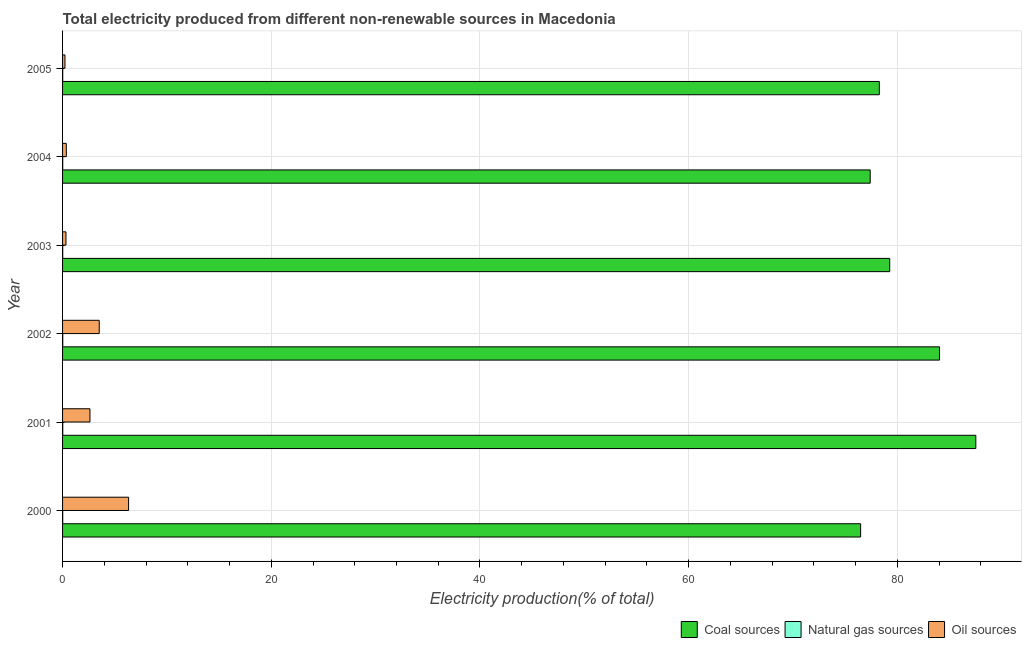Are the number of bars per tick equal to the number of legend labels?
Your answer should be compact. Yes. Are the number of bars on each tick of the Y-axis equal?
Your answer should be compact. Yes. How many bars are there on the 3rd tick from the bottom?
Your response must be concise. 3. What is the label of the 6th group of bars from the top?
Give a very brief answer. 2000. In how many cases, is the number of bars for a given year not equal to the number of legend labels?
Your answer should be very brief. 0. What is the percentage of electricity produced by coal in 2005?
Offer a terse response. 78.27. Across all years, what is the maximum percentage of electricity produced by coal?
Provide a short and direct response. 87.52. Across all years, what is the minimum percentage of electricity produced by oil sources?
Your answer should be compact. 0.23. What is the total percentage of electricity produced by coal in the graph?
Give a very brief answer. 482.98. What is the difference between the percentage of electricity produced by oil sources in 2000 and that in 2001?
Your response must be concise. 3.7. What is the difference between the percentage of electricity produced by coal in 2000 and the percentage of electricity produced by natural gas in 2003?
Make the answer very short. 76.46. What is the average percentage of electricity produced by natural gas per year?
Your answer should be compact. 0.01. In the year 2005, what is the difference between the percentage of electricity produced by natural gas and percentage of electricity produced by coal?
Offer a terse response. -78.26. In how many years, is the percentage of electricity produced by coal greater than 12 %?
Give a very brief answer. 6. What is the ratio of the percentage of electricity produced by oil sources in 2001 to that in 2005?
Keep it short and to the point. 11.39. Is the percentage of electricity produced by coal in 2002 less than that in 2003?
Provide a succinct answer. No. Is the difference between the percentage of electricity produced by coal in 2001 and 2002 greater than the difference between the percentage of electricity produced by oil sources in 2001 and 2002?
Keep it short and to the point. Yes. What is the difference between the highest and the second highest percentage of electricity produced by oil sources?
Ensure brevity in your answer.  2.81. What is the difference between the highest and the lowest percentage of electricity produced by natural gas?
Offer a terse response. 0. What does the 3rd bar from the top in 2004 represents?
Your response must be concise. Coal sources. What does the 2nd bar from the bottom in 2004 represents?
Your answer should be compact. Natural gas sources. Is it the case that in every year, the sum of the percentage of electricity produced by coal and percentage of electricity produced by natural gas is greater than the percentage of electricity produced by oil sources?
Your response must be concise. Yes. How many years are there in the graph?
Keep it short and to the point. 6. Are the values on the major ticks of X-axis written in scientific E-notation?
Keep it short and to the point. No. Where does the legend appear in the graph?
Your response must be concise. Bottom right. How many legend labels are there?
Your answer should be compact. 3. What is the title of the graph?
Give a very brief answer. Total electricity produced from different non-renewable sources in Macedonia. What is the label or title of the X-axis?
Keep it short and to the point. Electricity production(% of total). What is the Electricity production(% of total) in Coal sources in 2000?
Your answer should be very brief. 76.48. What is the Electricity production(% of total) of Natural gas sources in 2000?
Offer a terse response. 0.01. What is the Electricity production(% of total) in Oil sources in 2000?
Offer a terse response. 6.33. What is the Electricity production(% of total) in Coal sources in 2001?
Make the answer very short. 87.52. What is the Electricity production(% of total) in Natural gas sources in 2001?
Your response must be concise. 0.02. What is the Electricity production(% of total) of Oil sources in 2001?
Your response must be concise. 2.62. What is the Electricity production(% of total) in Coal sources in 2002?
Provide a succinct answer. 84.04. What is the Electricity production(% of total) of Natural gas sources in 2002?
Keep it short and to the point. 0.02. What is the Electricity production(% of total) in Oil sources in 2002?
Make the answer very short. 3.51. What is the Electricity production(% of total) in Coal sources in 2003?
Offer a terse response. 79.27. What is the Electricity production(% of total) in Natural gas sources in 2003?
Your answer should be very brief. 0.01. What is the Electricity production(% of total) in Oil sources in 2003?
Offer a very short reply. 0.33. What is the Electricity production(% of total) in Coal sources in 2004?
Ensure brevity in your answer.  77.4. What is the Electricity production(% of total) of Natural gas sources in 2004?
Make the answer very short. 0.01. What is the Electricity production(% of total) of Oil sources in 2004?
Offer a very short reply. 0.36. What is the Electricity production(% of total) in Coal sources in 2005?
Offer a terse response. 78.27. What is the Electricity production(% of total) in Natural gas sources in 2005?
Give a very brief answer. 0.01. What is the Electricity production(% of total) in Oil sources in 2005?
Provide a short and direct response. 0.23. Across all years, what is the maximum Electricity production(% of total) of Coal sources?
Make the answer very short. 87.52. Across all years, what is the maximum Electricity production(% of total) in Natural gas sources?
Your answer should be very brief. 0.02. Across all years, what is the maximum Electricity production(% of total) of Oil sources?
Provide a short and direct response. 6.33. Across all years, what is the minimum Electricity production(% of total) in Coal sources?
Offer a very short reply. 76.48. Across all years, what is the minimum Electricity production(% of total) in Natural gas sources?
Provide a succinct answer. 0.01. Across all years, what is the minimum Electricity production(% of total) in Oil sources?
Your answer should be very brief. 0.23. What is the total Electricity production(% of total) in Coal sources in the graph?
Offer a very short reply. 482.98. What is the total Electricity production(% of total) in Natural gas sources in the graph?
Your answer should be very brief. 0.09. What is the total Electricity production(% of total) in Oil sources in the graph?
Ensure brevity in your answer.  13.38. What is the difference between the Electricity production(% of total) of Coal sources in 2000 and that in 2001?
Provide a short and direct response. -11.04. What is the difference between the Electricity production(% of total) in Natural gas sources in 2000 and that in 2001?
Give a very brief answer. -0. What is the difference between the Electricity production(% of total) in Oil sources in 2000 and that in 2001?
Your answer should be compact. 3.7. What is the difference between the Electricity production(% of total) in Coal sources in 2000 and that in 2002?
Provide a short and direct response. -7.56. What is the difference between the Electricity production(% of total) in Natural gas sources in 2000 and that in 2002?
Offer a terse response. -0. What is the difference between the Electricity production(% of total) in Oil sources in 2000 and that in 2002?
Give a very brief answer. 2.81. What is the difference between the Electricity production(% of total) of Coal sources in 2000 and that in 2003?
Provide a short and direct response. -2.79. What is the difference between the Electricity production(% of total) of Natural gas sources in 2000 and that in 2003?
Provide a succinct answer. -0. What is the difference between the Electricity production(% of total) of Oil sources in 2000 and that in 2003?
Give a very brief answer. 6. What is the difference between the Electricity production(% of total) in Coal sources in 2000 and that in 2004?
Make the answer very short. -0.92. What is the difference between the Electricity production(% of total) of Natural gas sources in 2000 and that in 2004?
Provide a succinct answer. -0. What is the difference between the Electricity production(% of total) in Oil sources in 2000 and that in 2004?
Offer a terse response. 5.97. What is the difference between the Electricity production(% of total) of Coal sources in 2000 and that in 2005?
Give a very brief answer. -1.79. What is the difference between the Electricity production(% of total) in Oil sources in 2000 and that in 2005?
Offer a terse response. 6.1. What is the difference between the Electricity production(% of total) of Coal sources in 2001 and that in 2002?
Provide a short and direct response. 3.48. What is the difference between the Electricity production(% of total) of Natural gas sources in 2001 and that in 2002?
Offer a very short reply. -0. What is the difference between the Electricity production(% of total) in Oil sources in 2001 and that in 2002?
Your answer should be very brief. -0.89. What is the difference between the Electricity production(% of total) of Coal sources in 2001 and that in 2003?
Offer a terse response. 8.25. What is the difference between the Electricity production(% of total) of Natural gas sources in 2001 and that in 2003?
Your response must be concise. 0. What is the difference between the Electricity production(% of total) in Oil sources in 2001 and that in 2003?
Provide a succinct answer. 2.3. What is the difference between the Electricity production(% of total) in Coal sources in 2001 and that in 2004?
Provide a succinct answer. 10.12. What is the difference between the Electricity production(% of total) of Natural gas sources in 2001 and that in 2004?
Offer a terse response. 0. What is the difference between the Electricity production(% of total) of Oil sources in 2001 and that in 2004?
Give a very brief answer. 2.27. What is the difference between the Electricity production(% of total) of Coal sources in 2001 and that in 2005?
Offer a very short reply. 9.25. What is the difference between the Electricity production(% of total) of Natural gas sources in 2001 and that in 2005?
Keep it short and to the point. 0. What is the difference between the Electricity production(% of total) in Oil sources in 2001 and that in 2005?
Provide a short and direct response. 2.39. What is the difference between the Electricity production(% of total) of Coal sources in 2002 and that in 2003?
Your response must be concise. 4.78. What is the difference between the Electricity production(% of total) of Natural gas sources in 2002 and that in 2003?
Your response must be concise. 0. What is the difference between the Electricity production(% of total) in Oil sources in 2002 and that in 2003?
Give a very brief answer. 3.19. What is the difference between the Electricity production(% of total) in Coal sources in 2002 and that in 2004?
Offer a terse response. 6.65. What is the difference between the Electricity production(% of total) of Natural gas sources in 2002 and that in 2004?
Give a very brief answer. 0. What is the difference between the Electricity production(% of total) of Oil sources in 2002 and that in 2004?
Provide a short and direct response. 3.15. What is the difference between the Electricity production(% of total) in Coal sources in 2002 and that in 2005?
Give a very brief answer. 5.77. What is the difference between the Electricity production(% of total) in Natural gas sources in 2002 and that in 2005?
Provide a short and direct response. 0. What is the difference between the Electricity production(% of total) of Oil sources in 2002 and that in 2005?
Ensure brevity in your answer.  3.28. What is the difference between the Electricity production(% of total) of Coal sources in 2003 and that in 2004?
Provide a short and direct response. 1.87. What is the difference between the Electricity production(% of total) of Natural gas sources in 2003 and that in 2004?
Your answer should be very brief. -0. What is the difference between the Electricity production(% of total) of Oil sources in 2003 and that in 2004?
Provide a short and direct response. -0.03. What is the difference between the Electricity production(% of total) of Coal sources in 2003 and that in 2005?
Ensure brevity in your answer.  0.99. What is the difference between the Electricity production(% of total) in Natural gas sources in 2003 and that in 2005?
Your answer should be compact. 0. What is the difference between the Electricity production(% of total) of Oil sources in 2003 and that in 2005?
Give a very brief answer. 0.1. What is the difference between the Electricity production(% of total) of Coal sources in 2004 and that in 2005?
Your answer should be very brief. -0.88. What is the difference between the Electricity production(% of total) of Natural gas sources in 2004 and that in 2005?
Provide a succinct answer. 0. What is the difference between the Electricity production(% of total) in Oil sources in 2004 and that in 2005?
Provide a succinct answer. 0.13. What is the difference between the Electricity production(% of total) in Coal sources in 2000 and the Electricity production(% of total) in Natural gas sources in 2001?
Your answer should be very brief. 76.46. What is the difference between the Electricity production(% of total) in Coal sources in 2000 and the Electricity production(% of total) in Oil sources in 2001?
Offer a terse response. 73.85. What is the difference between the Electricity production(% of total) in Natural gas sources in 2000 and the Electricity production(% of total) in Oil sources in 2001?
Keep it short and to the point. -2.61. What is the difference between the Electricity production(% of total) in Coal sources in 2000 and the Electricity production(% of total) in Natural gas sources in 2002?
Make the answer very short. 76.46. What is the difference between the Electricity production(% of total) in Coal sources in 2000 and the Electricity production(% of total) in Oil sources in 2002?
Provide a succinct answer. 72.97. What is the difference between the Electricity production(% of total) in Natural gas sources in 2000 and the Electricity production(% of total) in Oil sources in 2002?
Offer a terse response. -3.5. What is the difference between the Electricity production(% of total) of Coal sources in 2000 and the Electricity production(% of total) of Natural gas sources in 2003?
Offer a very short reply. 76.46. What is the difference between the Electricity production(% of total) of Coal sources in 2000 and the Electricity production(% of total) of Oil sources in 2003?
Make the answer very short. 76.15. What is the difference between the Electricity production(% of total) in Natural gas sources in 2000 and the Electricity production(% of total) in Oil sources in 2003?
Your answer should be very brief. -0.31. What is the difference between the Electricity production(% of total) in Coal sources in 2000 and the Electricity production(% of total) in Natural gas sources in 2004?
Keep it short and to the point. 76.46. What is the difference between the Electricity production(% of total) in Coal sources in 2000 and the Electricity production(% of total) in Oil sources in 2004?
Make the answer very short. 76.12. What is the difference between the Electricity production(% of total) of Natural gas sources in 2000 and the Electricity production(% of total) of Oil sources in 2004?
Keep it short and to the point. -0.35. What is the difference between the Electricity production(% of total) in Coal sources in 2000 and the Electricity production(% of total) in Natural gas sources in 2005?
Keep it short and to the point. 76.46. What is the difference between the Electricity production(% of total) in Coal sources in 2000 and the Electricity production(% of total) in Oil sources in 2005?
Give a very brief answer. 76.25. What is the difference between the Electricity production(% of total) of Natural gas sources in 2000 and the Electricity production(% of total) of Oil sources in 2005?
Your response must be concise. -0.22. What is the difference between the Electricity production(% of total) of Coal sources in 2001 and the Electricity production(% of total) of Natural gas sources in 2002?
Keep it short and to the point. 87.5. What is the difference between the Electricity production(% of total) of Coal sources in 2001 and the Electricity production(% of total) of Oil sources in 2002?
Offer a terse response. 84.01. What is the difference between the Electricity production(% of total) of Natural gas sources in 2001 and the Electricity production(% of total) of Oil sources in 2002?
Offer a very short reply. -3.5. What is the difference between the Electricity production(% of total) in Coal sources in 2001 and the Electricity production(% of total) in Natural gas sources in 2003?
Provide a succinct answer. 87.5. What is the difference between the Electricity production(% of total) of Coal sources in 2001 and the Electricity production(% of total) of Oil sources in 2003?
Your answer should be compact. 87.19. What is the difference between the Electricity production(% of total) in Natural gas sources in 2001 and the Electricity production(% of total) in Oil sources in 2003?
Make the answer very short. -0.31. What is the difference between the Electricity production(% of total) in Coal sources in 2001 and the Electricity production(% of total) in Natural gas sources in 2004?
Provide a short and direct response. 87.5. What is the difference between the Electricity production(% of total) in Coal sources in 2001 and the Electricity production(% of total) in Oil sources in 2004?
Your answer should be very brief. 87.16. What is the difference between the Electricity production(% of total) in Natural gas sources in 2001 and the Electricity production(% of total) in Oil sources in 2004?
Provide a short and direct response. -0.34. What is the difference between the Electricity production(% of total) of Coal sources in 2001 and the Electricity production(% of total) of Natural gas sources in 2005?
Give a very brief answer. 87.51. What is the difference between the Electricity production(% of total) of Coal sources in 2001 and the Electricity production(% of total) of Oil sources in 2005?
Offer a very short reply. 87.29. What is the difference between the Electricity production(% of total) of Natural gas sources in 2001 and the Electricity production(% of total) of Oil sources in 2005?
Offer a terse response. -0.21. What is the difference between the Electricity production(% of total) of Coal sources in 2002 and the Electricity production(% of total) of Natural gas sources in 2003?
Offer a terse response. 84.03. What is the difference between the Electricity production(% of total) in Coal sources in 2002 and the Electricity production(% of total) in Oil sources in 2003?
Provide a short and direct response. 83.72. What is the difference between the Electricity production(% of total) of Natural gas sources in 2002 and the Electricity production(% of total) of Oil sources in 2003?
Offer a very short reply. -0.31. What is the difference between the Electricity production(% of total) of Coal sources in 2002 and the Electricity production(% of total) of Natural gas sources in 2004?
Offer a terse response. 84.03. What is the difference between the Electricity production(% of total) in Coal sources in 2002 and the Electricity production(% of total) in Oil sources in 2004?
Your answer should be compact. 83.68. What is the difference between the Electricity production(% of total) in Natural gas sources in 2002 and the Electricity production(% of total) in Oil sources in 2004?
Give a very brief answer. -0.34. What is the difference between the Electricity production(% of total) in Coal sources in 2002 and the Electricity production(% of total) in Natural gas sources in 2005?
Provide a succinct answer. 84.03. What is the difference between the Electricity production(% of total) in Coal sources in 2002 and the Electricity production(% of total) in Oil sources in 2005?
Your answer should be compact. 83.81. What is the difference between the Electricity production(% of total) in Natural gas sources in 2002 and the Electricity production(% of total) in Oil sources in 2005?
Your answer should be compact. -0.21. What is the difference between the Electricity production(% of total) of Coal sources in 2003 and the Electricity production(% of total) of Natural gas sources in 2004?
Your answer should be very brief. 79.25. What is the difference between the Electricity production(% of total) in Coal sources in 2003 and the Electricity production(% of total) in Oil sources in 2004?
Provide a succinct answer. 78.91. What is the difference between the Electricity production(% of total) in Natural gas sources in 2003 and the Electricity production(% of total) in Oil sources in 2004?
Give a very brief answer. -0.35. What is the difference between the Electricity production(% of total) in Coal sources in 2003 and the Electricity production(% of total) in Natural gas sources in 2005?
Ensure brevity in your answer.  79.25. What is the difference between the Electricity production(% of total) of Coal sources in 2003 and the Electricity production(% of total) of Oil sources in 2005?
Keep it short and to the point. 79.04. What is the difference between the Electricity production(% of total) in Natural gas sources in 2003 and the Electricity production(% of total) in Oil sources in 2005?
Offer a terse response. -0.22. What is the difference between the Electricity production(% of total) of Coal sources in 2004 and the Electricity production(% of total) of Natural gas sources in 2005?
Your answer should be compact. 77.38. What is the difference between the Electricity production(% of total) in Coal sources in 2004 and the Electricity production(% of total) in Oil sources in 2005?
Ensure brevity in your answer.  77.17. What is the difference between the Electricity production(% of total) of Natural gas sources in 2004 and the Electricity production(% of total) of Oil sources in 2005?
Make the answer very short. -0.22. What is the average Electricity production(% of total) of Coal sources per year?
Provide a short and direct response. 80.5. What is the average Electricity production(% of total) of Natural gas sources per year?
Offer a very short reply. 0.02. What is the average Electricity production(% of total) in Oil sources per year?
Your answer should be very brief. 2.23. In the year 2000, what is the difference between the Electricity production(% of total) in Coal sources and Electricity production(% of total) in Natural gas sources?
Offer a terse response. 76.46. In the year 2000, what is the difference between the Electricity production(% of total) of Coal sources and Electricity production(% of total) of Oil sources?
Provide a succinct answer. 70.15. In the year 2000, what is the difference between the Electricity production(% of total) in Natural gas sources and Electricity production(% of total) in Oil sources?
Keep it short and to the point. -6.31. In the year 2001, what is the difference between the Electricity production(% of total) of Coal sources and Electricity production(% of total) of Natural gas sources?
Provide a succinct answer. 87.5. In the year 2001, what is the difference between the Electricity production(% of total) in Coal sources and Electricity production(% of total) in Oil sources?
Give a very brief answer. 84.89. In the year 2001, what is the difference between the Electricity production(% of total) in Natural gas sources and Electricity production(% of total) in Oil sources?
Your response must be concise. -2.61. In the year 2002, what is the difference between the Electricity production(% of total) in Coal sources and Electricity production(% of total) in Natural gas sources?
Offer a very short reply. 84.03. In the year 2002, what is the difference between the Electricity production(% of total) in Coal sources and Electricity production(% of total) in Oil sources?
Make the answer very short. 80.53. In the year 2002, what is the difference between the Electricity production(% of total) of Natural gas sources and Electricity production(% of total) of Oil sources?
Your answer should be very brief. -3.5. In the year 2003, what is the difference between the Electricity production(% of total) of Coal sources and Electricity production(% of total) of Natural gas sources?
Your answer should be very brief. 79.25. In the year 2003, what is the difference between the Electricity production(% of total) in Coal sources and Electricity production(% of total) in Oil sources?
Provide a short and direct response. 78.94. In the year 2003, what is the difference between the Electricity production(% of total) of Natural gas sources and Electricity production(% of total) of Oil sources?
Provide a succinct answer. -0.31. In the year 2004, what is the difference between the Electricity production(% of total) in Coal sources and Electricity production(% of total) in Natural gas sources?
Provide a short and direct response. 77.38. In the year 2004, what is the difference between the Electricity production(% of total) of Coal sources and Electricity production(% of total) of Oil sources?
Your answer should be very brief. 77.04. In the year 2004, what is the difference between the Electricity production(% of total) of Natural gas sources and Electricity production(% of total) of Oil sources?
Offer a very short reply. -0.34. In the year 2005, what is the difference between the Electricity production(% of total) of Coal sources and Electricity production(% of total) of Natural gas sources?
Ensure brevity in your answer.  78.26. In the year 2005, what is the difference between the Electricity production(% of total) of Coal sources and Electricity production(% of total) of Oil sources?
Give a very brief answer. 78.04. In the year 2005, what is the difference between the Electricity production(% of total) of Natural gas sources and Electricity production(% of total) of Oil sources?
Give a very brief answer. -0.22. What is the ratio of the Electricity production(% of total) of Coal sources in 2000 to that in 2001?
Keep it short and to the point. 0.87. What is the ratio of the Electricity production(% of total) in Natural gas sources in 2000 to that in 2001?
Provide a short and direct response. 0.93. What is the ratio of the Electricity production(% of total) in Oil sources in 2000 to that in 2001?
Your response must be concise. 2.41. What is the ratio of the Electricity production(% of total) in Coal sources in 2000 to that in 2002?
Your response must be concise. 0.91. What is the ratio of the Electricity production(% of total) in Natural gas sources in 2000 to that in 2002?
Ensure brevity in your answer.  0.89. What is the ratio of the Electricity production(% of total) of Oil sources in 2000 to that in 2002?
Keep it short and to the point. 1.8. What is the ratio of the Electricity production(% of total) of Coal sources in 2000 to that in 2003?
Provide a short and direct response. 0.96. What is the ratio of the Electricity production(% of total) of Natural gas sources in 2000 to that in 2003?
Make the answer very short. 0.99. What is the ratio of the Electricity production(% of total) of Oil sources in 2000 to that in 2003?
Ensure brevity in your answer.  19.38. What is the ratio of the Electricity production(% of total) of Coal sources in 2000 to that in 2004?
Your response must be concise. 0.99. What is the ratio of the Electricity production(% of total) of Natural gas sources in 2000 to that in 2004?
Provide a short and direct response. 0.98. What is the ratio of the Electricity production(% of total) of Oil sources in 2000 to that in 2004?
Make the answer very short. 17.58. What is the ratio of the Electricity production(% of total) of Coal sources in 2000 to that in 2005?
Ensure brevity in your answer.  0.98. What is the ratio of the Electricity production(% of total) of Natural gas sources in 2000 to that in 2005?
Your answer should be very brief. 1.02. What is the ratio of the Electricity production(% of total) in Oil sources in 2000 to that in 2005?
Your answer should be compact. 27.47. What is the ratio of the Electricity production(% of total) of Coal sources in 2001 to that in 2002?
Your answer should be compact. 1.04. What is the ratio of the Electricity production(% of total) of Natural gas sources in 2001 to that in 2002?
Keep it short and to the point. 0.96. What is the ratio of the Electricity production(% of total) of Oil sources in 2001 to that in 2002?
Give a very brief answer. 0.75. What is the ratio of the Electricity production(% of total) in Coal sources in 2001 to that in 2003?
Ensure brevity in your answer.  1.1. What is the ratio of the Electricity production(% of total) in Natural gas sources in 2001 to that in 2003?
Provide a succinct answer. 1.06. What is the ratio of the Electricity production(% of total) in Oil sources in 2001 to that in 2003?
Offer a terse response. 8.04. What is the ratio of the Electricity production(% of total) of Coal sources in 2001 to that in 2004?
Your response must be concise. 1.13. What is the ratio of the Electricity production(% of total) of Natural gas sources in 2001 to that in 2004?
Keep it short and to the point. 1.05. What is the ratio of the Electricity production(% of total) of Oil sources in 2001 to that in 2004?
Keep it short and to the point. 7.29. What is the ratio of the Electricity production(% of total) of Coal sources in 2001 to that in 2005?
Your response must be concise. 1.12. What is the ratio of the Electricity production(% of total) in Natural gas sources in 2001 to that in 2005?
Ensure brevity in your answer.  1.09. What is the ratio of the Electricity production(% of total) in Oil sources in 2001 to that in 2005?
Offer a terse response. 11.39. What is the ratio of the Electricity production(% of total) of Coal sources in 2002 to that in 2003?
Offer a very short reply. 1.06. What is the ratio of the Electricity production(% of total) of Natural gas sources in 2002 to that in 2003?
Your answer should be very brief. 1.11. What is the ratio of the Electricity production(% of total) in Oil sources in 2002 to that in 2003?
Your answer should be compact. 10.76. What is the ratio of the Electricity production(% of total) in Coal sources in 2002 to that in 2004?
Ensure brevity in your answer.  1.09. What is the ratio of the Electricity production(% of total) in Natural gas sources in 2002 to that in 2004?
Ensure brevity in your answer.  1.09. What is the ratio of the Electricity production(% of total) in Oil sources in 2002 to that in 2004?
Your response must be concise. 9.76. What is the ratio of the Electricity production(% of total) of Coal sources in 2002 to that in 2005?
Your answer should be compact. 1.07. What is the ratio of the Electricity production(% of total) of Natural gas sources in 2002 to that in 2005?
Make the answer very short. 1.14. What is the ratio of the Electricity production(% of total) of Oil sources in 2002 to that in 2005?
Offer a terse response. 15.25. What is the ratio of the Electricity production(% of total) in Coal sources in 2003 to that in 2004?
Your answer should be compact. 1.02. What is the ratio of the Electricity production(% of total) in Natural gas sources in 2003 to that in 2004?
Ensure brevity in your answer.  0.99. What is the ratio of the Electricity production(% of total) in Oil sources in 2003 to that in 2004?
Offer a terse response. 0.91. What is the ratio of the Electricity production(% of total) in Coal sources in 2003 to that in 2005?
Your response must be concise. 1.01. What is the ratio of the Electricity production(% of total) of Natural gas sources in 2003 to that in 2005?
Your answer should be compact. 1.03. What is the ratio of the Electricity production(% of total) of Oil sources in 2003 to that in 2005?
Make the answer very short. 1.42. What is the ratio of the Electricity production(% of total) of Coal sources in 2004 to that in 2005?
Your answer should be compact. 0.99. What is the ratio of the Electricity production(% of total) of Natural gas sources in 2004 to that in 2005?
Provide a succinct answer. 1.04. What is the ratio of the Electricity production(% of total) in Oil sources in 2004 to that in 2005?
Make the answer very short. 1.56. What is the difference between the highest and the second highest Electricity production(% of total) of Coal sources?
Make the answer very short. 3.48. What is the difference between the highest and the second highest Electricity production(% of total) in Natural gas sources?
Make the answer very short. 0. What is the difference between the highest and the second highest Electricity production(% of total) in Oil sources?
Give a very brief answer. 2.81. What is the difference between the highest and the lowest Electricity production(% of total) of Coal sources?
Provide a succinct answer. 11.04. What is the difference between the highest and the lowest Electricity production(% of total) of Natural gas sources?
Give a very brief answer. 0. What is the difference between the highest and the lowest Electricity production(% of total) of Oil sources?
Your response must be concise. 6.1. 